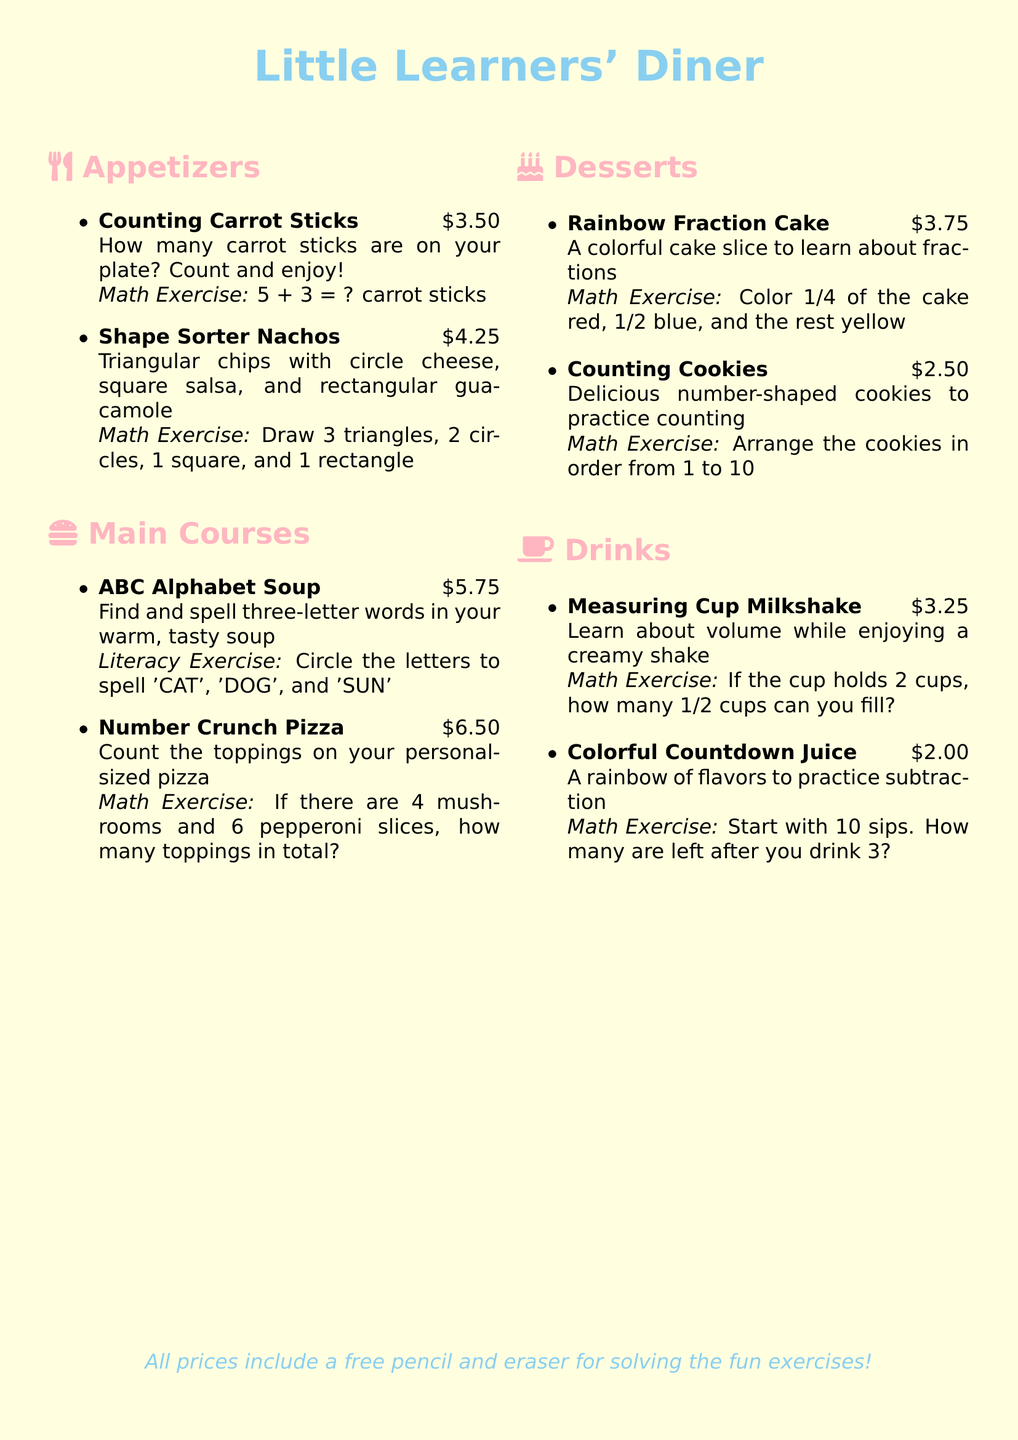What is the name of the diner? The title at the top of the document provides the name of the diner, which is "Little Learners' Diner."
Answer: Little Learners' Diner How much do the Counting Carrot Sticks cost? The price listed next to the Counting Carrot Sticks in the appetizer section shows the cost.
Answer: $3.50 What math exercise is associated with Shape Sorter Nachos? The document states that the math exercise for Shape Sorter Nachos involves drawing various shapes.
Answer: Draw 3 triangles, 2 circles, 1 square, and 1 rectangle How many total toppings are on the Number Crunch Pizza? The math exercise related to the Number Crunch Pizza calculates the total toppings based on given amounts.
Answer: 10 toppings What fraction of the Rainbow Fraction Cake is colored red? The document specifies the fraction that should be colored red in the Rainbow Fraction Cake.
Answer: 1/4 What exercise do the Counting Cookies provide? The exercise associated with Counting Cookies involves arranging them in a specific order.
Answer: Arrange the cookies in order from 1 to 10 How much is the Measuring Cup Milkshake? The listed price for the Measuring Cup Milkshake is found in the drinks section.
Answer: $3.25 What is the initial number of sips in the Colorful Countdown Juice exercise? The math exercise for Colorful Countdown Juice starts with a certain number of sips before subtracting.
Answer: 10 sips What is included for free with all prices? The document mentions an additional item included with the prices.
Answer: A free pencil and eraser 